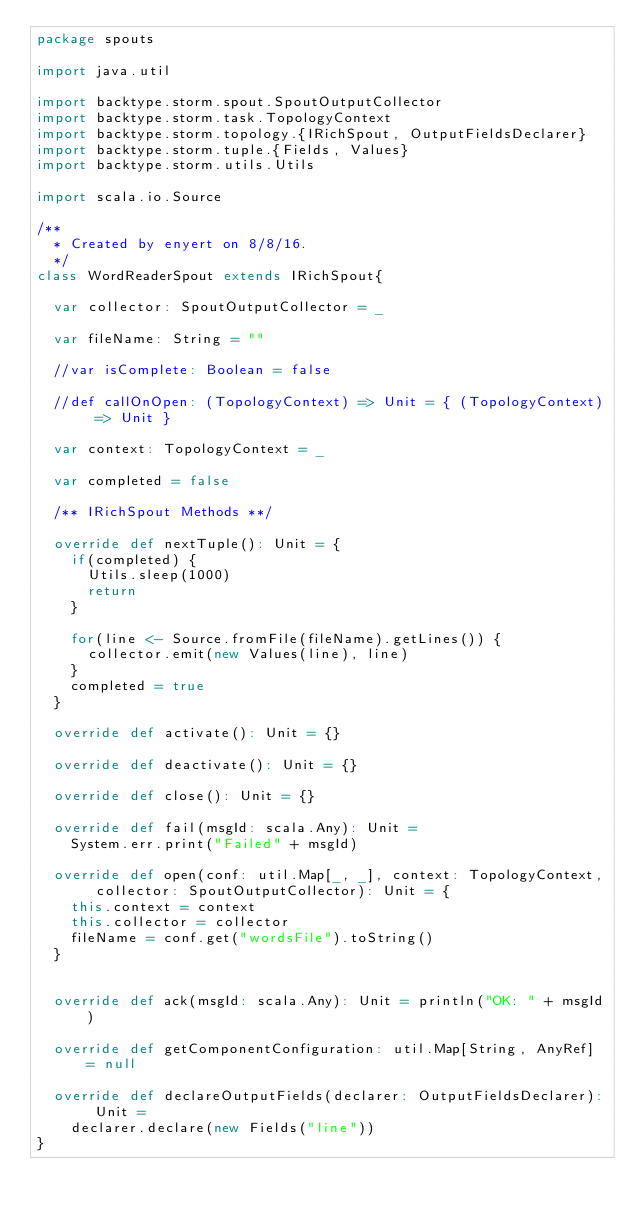<code> <loc_0><loc_0><loc_500><loc_500><_Scala_>package spouts

import java.util

import backtype.storm.spout.SpoutOutputCollector
import backtype.storm.task.TopologyContext
import backtype.storm.topology.{IRichSpout, OutputFieldsDeclarer}
import backtype.storm.tuple.{Fields, Values}
import backtype.storm.utils.Utils

import scala.io.Source

/**
  * Created by enyert on 8/8/16.
  */
class WordReaderSpout extends IRichSpout{

  var collector: SpoutOutputCollector = _

  var fileName: String = ""

  //var isComplete: Boolean = false

  //def callOnOpen: (TopologyContext) => Unit = { (TopologyContext) => Unit }

  var context: TopologyContext = _

  var completed = false

  /** IRichSpout Methods **/

  override def nextTuple(): Unit = {
    if(completed) {
      Utils.sleep(1000)
      return
    }

    for(line <- Source.fromFile(fileName).getLines()) {
      collector.emit(new Values(line), line)
    }
    completed = true
  }

  override def activate(): Unit = {}

  override def deactivate(): Unit = {}

  override def close(): Unit = {}

  override def fail(msgId: scala.Any): Unit =
    System.err.print("Failed" + msgId)

  override def open(conf: util.Map[_, _], context: TopologyContext, collector: SpoutOutputCollector): Unit = {
    this.context = context
    this.collector = collector
    fileName = conf.get("wordsFile").toString()
  }


  override def ack(msgId: scala.Any): Unit = println("OK: " + msgId)

  override def getComponentConfiguration: util.Map[String, AnyRef] = null

  override def declareOutputFields(declarer: OutputFieldsDeclarer): Unit =
    declarer.declare(new Fields("line"))
}
</code> 